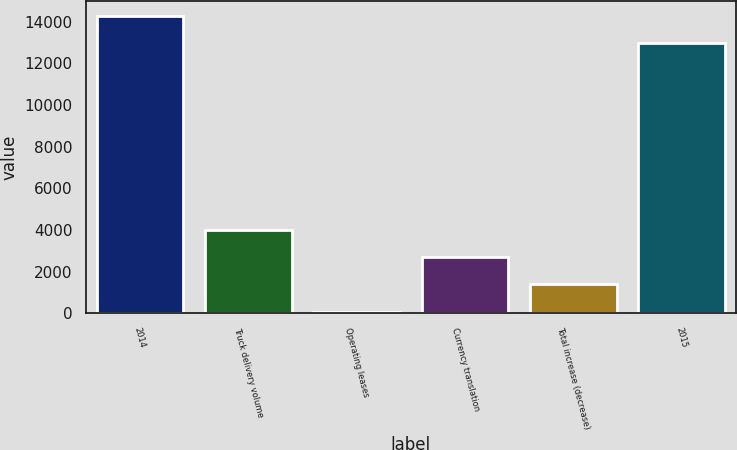Convert chart to OTSL. <chart><loc_0><loc_0><loc_500><loc_500><bar_chart><fcel>2014<fcel>Truck delivery volume<fcel>Operating leases<fcel>Currency translation<fcel>Total increase (decrease)<fcel>2015<nl><fcel>14281.3<fcel>3984.57<fcel>75.6<fcel>2681.58<fcel>1378.59<fcel>12978.3<nl></chart> 